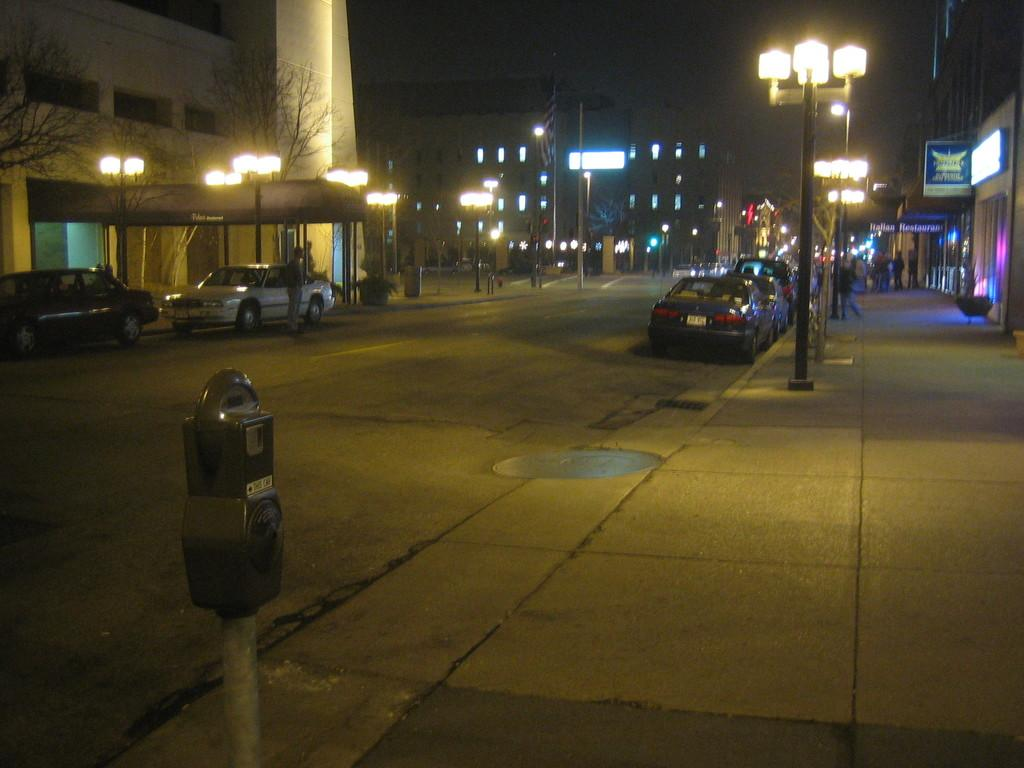What type of vehicles can be seen on the road in the image? There are cars on the road in the image. What structures are visible in the background? There are buildings visible in the image. What type of lighting is present along the road? Street lights are present on either side of the road. Where is the uncle standing in the image? There is no uncle present in the image. What type of vegetable is on the floor in the image? There is no vegetable, specifically celery, present in the image. 